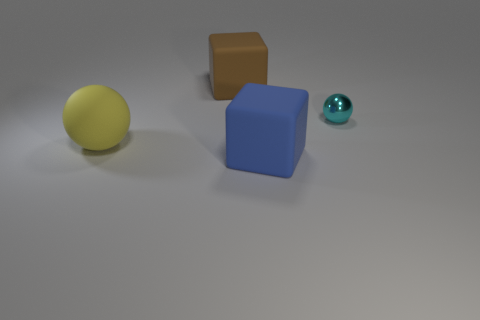Subtract all yellow spheres. How many spheres are left? 1 Add 1 big cyan rubber objects. How many objects exist? 5 Subtract all tiny green rubber cubes. Subtract all large yellow matte balls. How many objects are left? 3 Add 4 big brown matte cubes. How many big brown matte cubes are left? 5 Add 3 blue blocks. How many blue blocks exist? 4 Subtract 0 brown spheres. How many objects are left? 4 